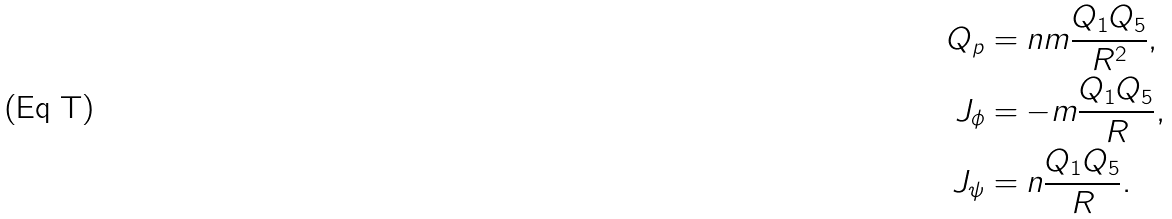Convert formula to latex. <formula><loc_0><loc_0><loc_500><loc_500>Q _ { p } & = n m \frac { Q _ { 1 } Q _ { 5 } } { R ^ { 2 } } , \\ J _ { \phi } & = - m \frac { Q _ { 1 } Q _ { 5 } } { R } , \\ J _ { \psi } & = n \frac { Q _ { 1 } Q _ { 5 } } { R } .</formula> 